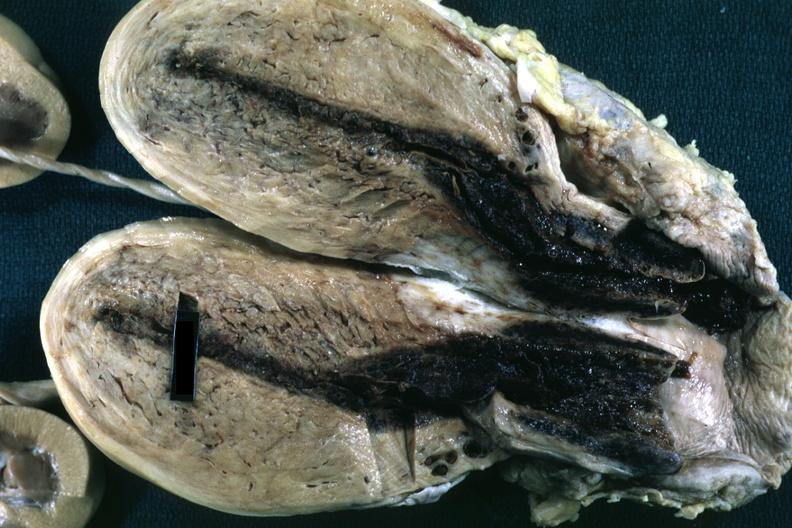what is fixed tissue opened?
Answer the question using a single word or phrase. Uterus with blood clot in cervical canal and small endometrial cavity 